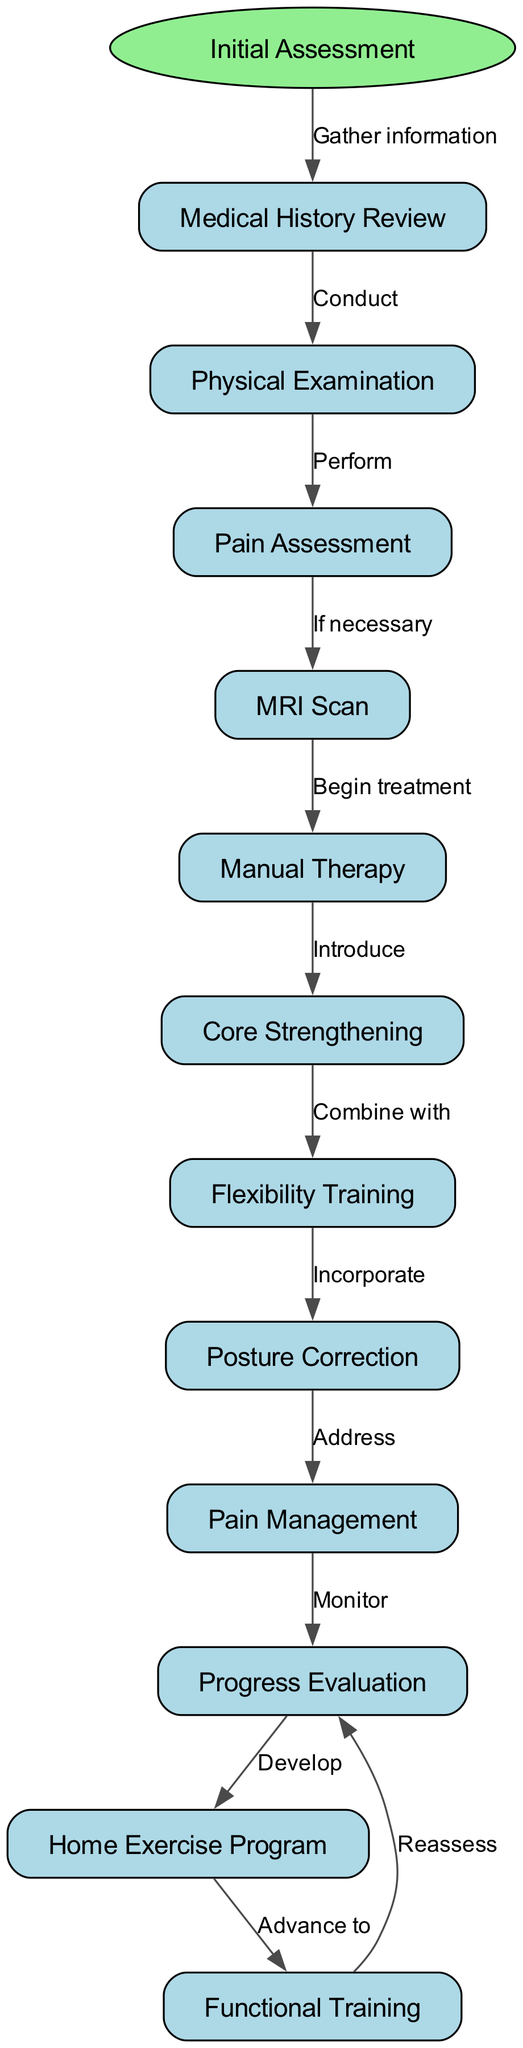What is the starting point of the clinical pathway? The starting point is explicitly stated in the diagram as "Initial Assessment." This is identified at the top of the diagram as the first step in the clinical pathway.
Answer: Initial Assessment How many nodes are present in the diagram? To find the number of nodes, count all the individual elements listed in the `nodes` array within the data. There are 12 distinct nodes including the starting point.
Answer: 12 What node follows 'Pain Assessment'? The edge leading out of 'Pain Assessment' points to 'MRI Scan', indicating that this is the next step if necessary after assessing pain.
Answer: MRI Scan What is introduced after 'Manual Therapy'? The edge that follows 'Manual Therapy' indicates the next step is 'Core Strengthening', meaning this is the treatment that is introduced next.
Answer: Core Strengthening Which node addresses pain management? Following the edges in the diagram, 'Pain Management' is mentioned after 'Posture Correction', indicating this is where pain management is addressed.
Answer: Pain Management What is developed after 'Progress Evaluation'? The pathway shows that after 'Progress Evaluation', a 'Home Exercise Program' is developed, highlighting the progression in the treatment plan.
Answer: Home Exercise Program Which two training types are combined together in the pathway? The flow indicates that 'Core Strengthening' is combined with 'Flexibility Training', as shown by the edge from core strengthening to flexibility training.
Answer: Core Strengthening and Flexibility Training What is the final node where progress is reassessed? The diagram indicates that after 'Functional Training', the pathway loops back to 'Progress Evaluation', suggesting that this is the step where progress is reassessed again.
Answer: Progress Evaluation Which node incorporates flexibility training? After 'Flexibility Training', the next step shown is 'Posture Correction', indicating that flexibility training is incorporated into this process.
Answer: Posture Correction 